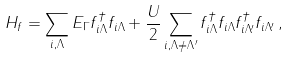Convert formula to latex. <formula><loc_0><loc_0><loc_500><loc_500>H _ { f } = \sum _ { { i } , \Lambda } E _ { \Gamma } f ^ { \dagger } _ { { i } \Lambda } f _ { { i } \Lambda } + \frac { U } { 2 } \sum _ { { i } , \Lambda \neq \Lambda ^ { \prime } } f ^ { \dagger } _ { { i } \Lambda } f _ { { i } \Lambda } f ^ { \dagger } _ { { i } \Lambda ^ { \prime } } f _ { { i } \Lambda ^ { \prime } } \, ,</formula> 